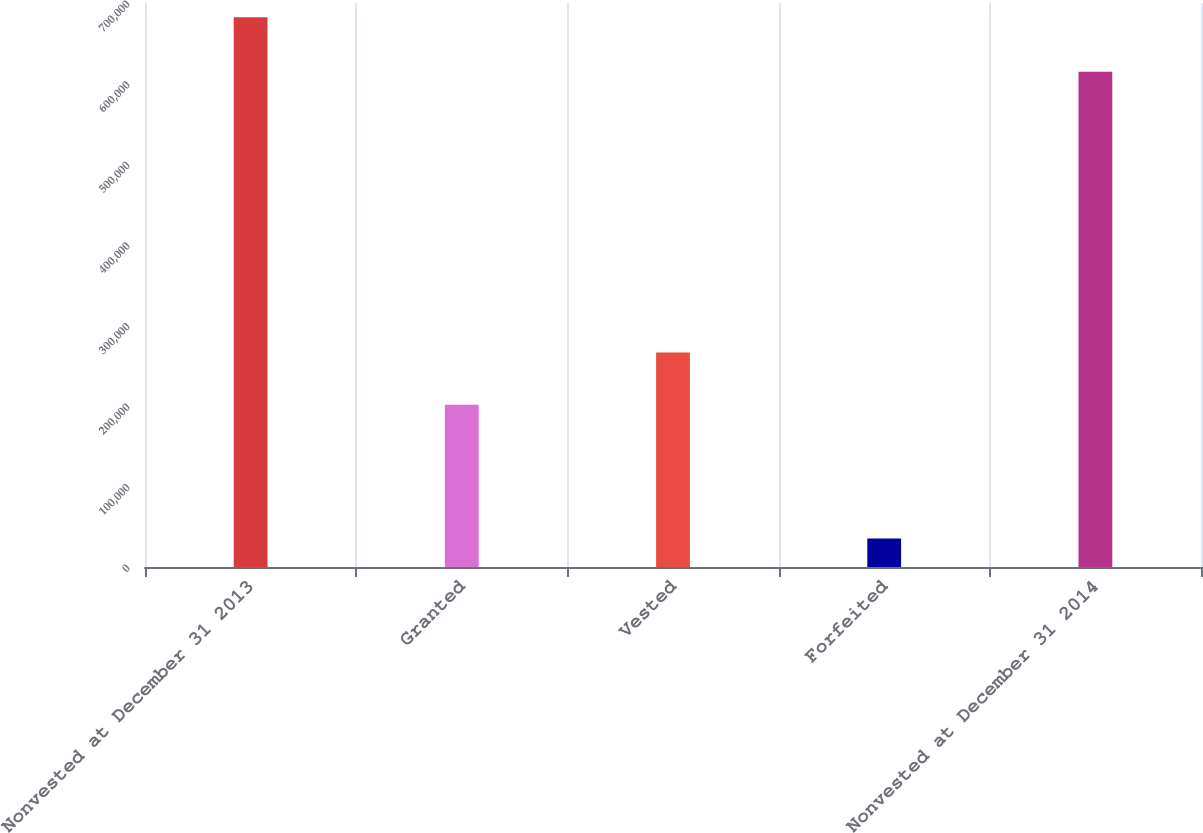Convert chart. <chart><loc_0><loc_0><loc_500><loc_500><bar_chart><fcel>Nonvested at December 31 2013<fcel>Granted<fcel>Vested<fcel>Forfeited<fcel>Nonvested at December 31 2014<nl><fcel>682347<fcel>201464<fcel>266160<fcel>35386<fcel>614666<nl></chart> 